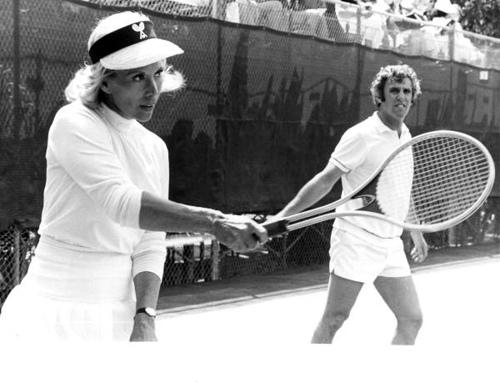What is the man wearing?
Write a very short answer. Shorts. Is this photo from this decade?
Quick response, please. No. What is the lady playing?
Quick response, please. Tennis. 